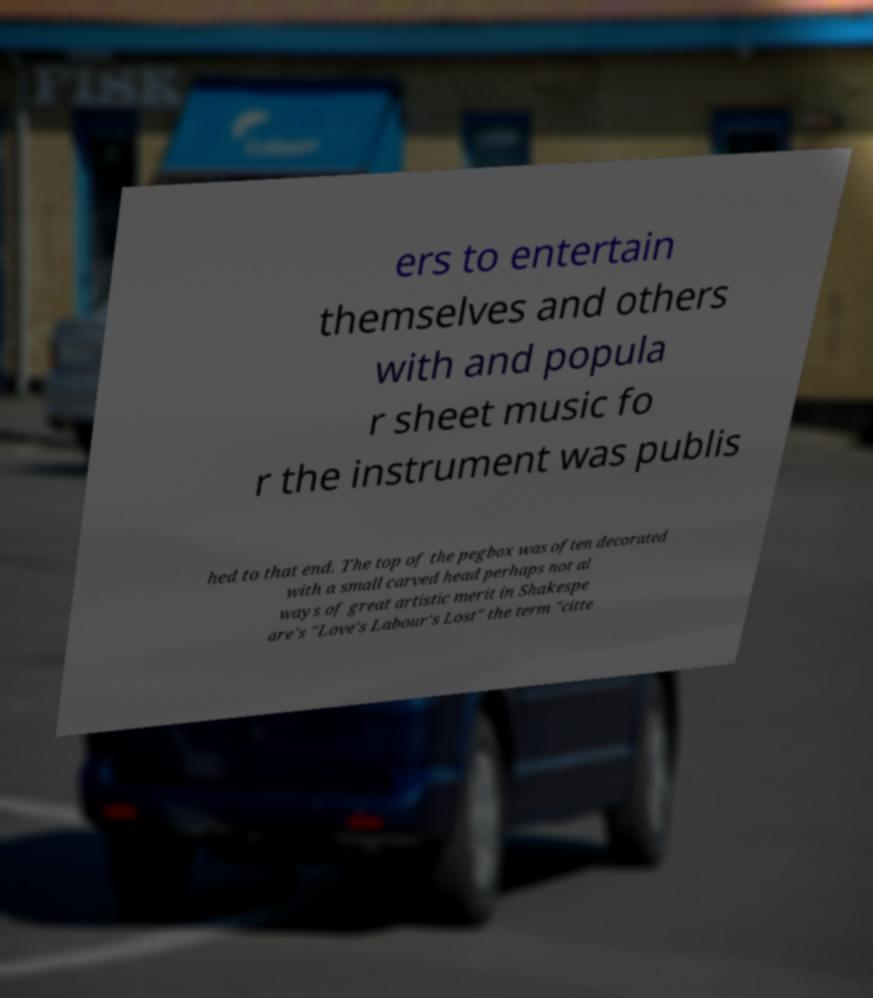Can you read and provide the text displayed in the image?This photo seems to have some interesting text. Can you extract and type it out for me? ers to entertain themselves and others with and popula r sheet music fo r the instrument was publis hed to that end. The top of the pegbox was often decorated with a small carved head perhaps not al ways of great artistic merit in Shakespe are's "Love's Labour's Lost" the term "citte 